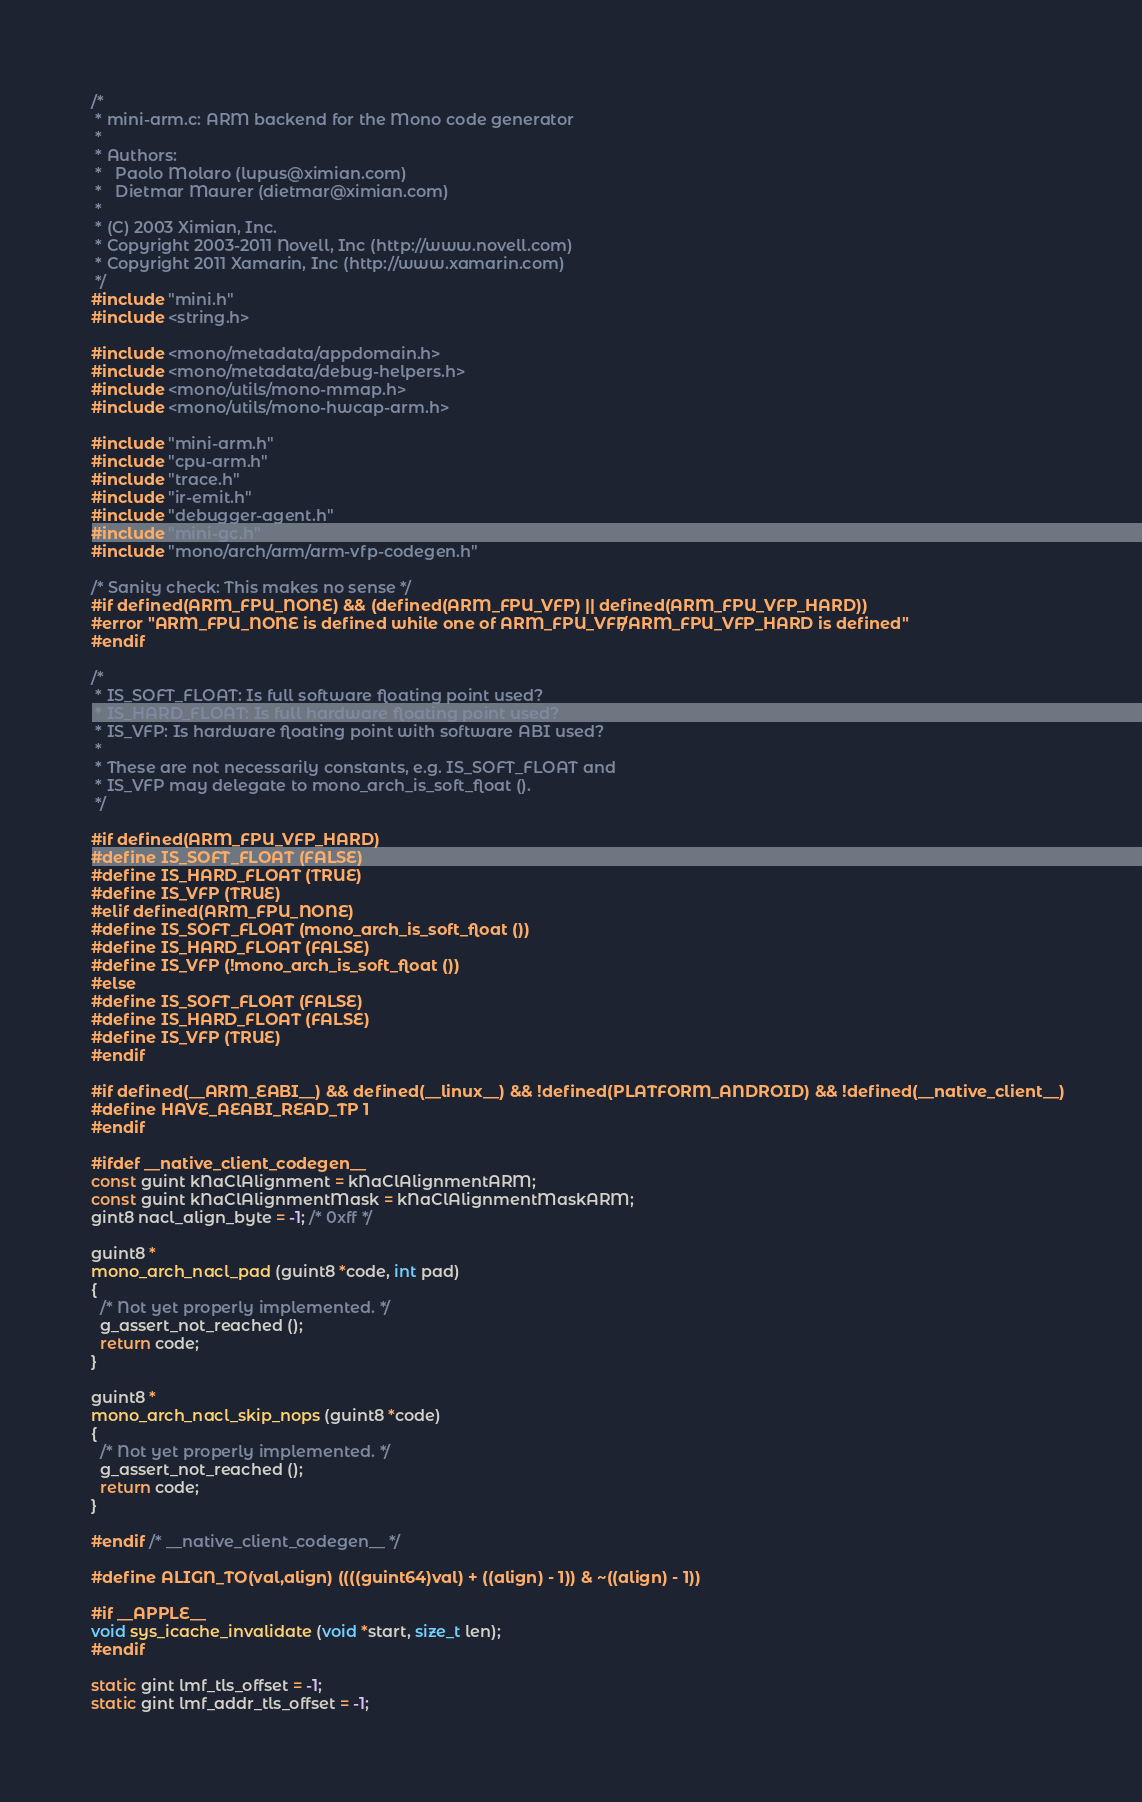Convert code to text. <code><loc_0><loc_0><loc_500><loc_500><_C_>/*
 * mini-arm.c: ARM backend for the Mono code generator
 *
 * Authors:
 *   Paolo Molaro (lupus@ximian.com)
 *   Dietmar Maurer (dietmar@ximian.com)
 *
 * (C) 2003 Ximian, Inc.
 * Copyright 2003-2011 Novell, Inc (http://www.novell.com)
 * Copyright 2011 Xamarin, Inc (http://www.xamarin.com)
 */
#include "mini.h"
#include <string.h>

#include <mono/metadata/appdomain.h>
#include <mono/metadata/debug-helpers.h>
#include <mono/utils/mono-mmap.h>
#include <mono/utils/mono-hwcap-arm.h>

#include "mini-arm.h"
#include "cpu-arm.h"
#include "trace.h"
#include "ir-emit.h"
#include "debugger-agent.h"
#include "mini-gc.h"
#include "mono/arch/arm/arm-vfp-codegen.h"

/* Sanity check: This makes no sense */
#if defined(ARM_FPU_NONE) && (defined(ARM_FPU_VFP) || defined(ARM_FPU_VFP_HARD))
#error "ARM_FPU_NONE is defined while one of ARM_FPU_VFP/ARM_FPU_VFP_HARD is defined"
#endif

/*
 * IS_SOFT_FLOAT: Is full software floating point used?
 * IS_HARD_FLOAT: Is full hardware floating point used?
 * IS_VFP: Is hardware floating point with software ABI used?
 *
 * These are not necessarily constants, e.g. IS_SOFT_FLOAT and
 * IS_VFP may delegate to mono_arch_is_soft_float ().
 */

#if defined(ARM_FPU_VFP_HARD)
#define IS_SOFT_FLOAT (FALSE)
#define IS_HARD_FLOAT (TRUE)
#define IS_VFP (TRUE)
#elif defined(ARM_FPU_NONE)
#define IS_SOFT_FLOAT (mono_arch_is_soft_float ())
#define IS_HARD_FLOAT (FALSE)
#define IS_VFP (!mono_arch_is_soft_float ())
#else
#define IS_SOFT_FLOAT (FALSE)
#define IS_HARD_FLOAT (FALSE)
#define IS_VFP (TRUE)
#endif

#if defined(__ARM_EABI__) && defined(__linux__) && !defined(PLATFORM_ANDROID) && !defined(__native_client__)
#define HAVE_AEABI_READ_TP 1
#endif

#ifdef __native_client_codegen__
const guint kNaClAlignment = kNaClAlignmentARM;
const guint kNaClAlignmentMask = kNaClAlignmentMaskARM;
gint8 nacl_align_byte = -1; /* 0xff */

guint8 *
mono_arch_nacl_pad (guint8 *code, int pad)
{
  /* Not yet properly implemented. */
  g_assert_not_reached ();
  return code;
}

guint8 *
mono_arch_nacl_skip_nops (guint8 *code)
{
  /* Not yet properly implemented. */
  g_assert_not_reached ();
  return code;
}

#endif /* __native_client_codegen__ */

#define ALIGN_TO(val,align) ((((guint64)val) + ((align) - 1)) & ~((align) - 1))

#if __APPLE__
void sys_icache_invalidate (void *start, size_t len);
#endif

static gint lmf_tls_offset = -1;
static gint lmf_addr_tls_offset = -1;
</code> 